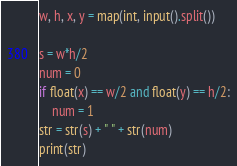Convert code to text. <code><loc_0><loc_0><loc_500><loc_500><_Python_>w, h, x, y = map(int, input().split())

s = w*h/2
num = 0
if float(x) == w/2 and float(y) == h/2:
	num = 1
str = str(s) + " " + str(num)
print(str)</code> 